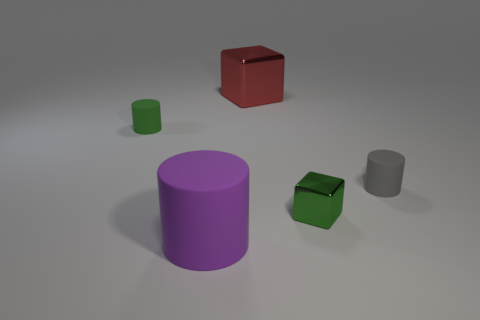Subtract all gray matte cylinders. How many cylinders are left? 2 Add 2 red shiny blocks. How many objects exist? 7 Subtract 1 cubes. How many cubes are left? 1 Subtract all green cylinders. How many cylinders are left? 2 Subtract all cylinders. How many objects are left? 2 Add 5 tiny green things. How many tiny green things are left? 7 Add 1 large brown rubber cylinders. How many large brown rubber cylinders exist? 1 Subtract 1 green cylinders. How many objects are left? 4 Subtract all red cubes. Subtract all brown balls. How many cubes are left? 1 Subtract all big cyan rubber cylinders. Subtract all tiny metal things. How many objects are left? 4 